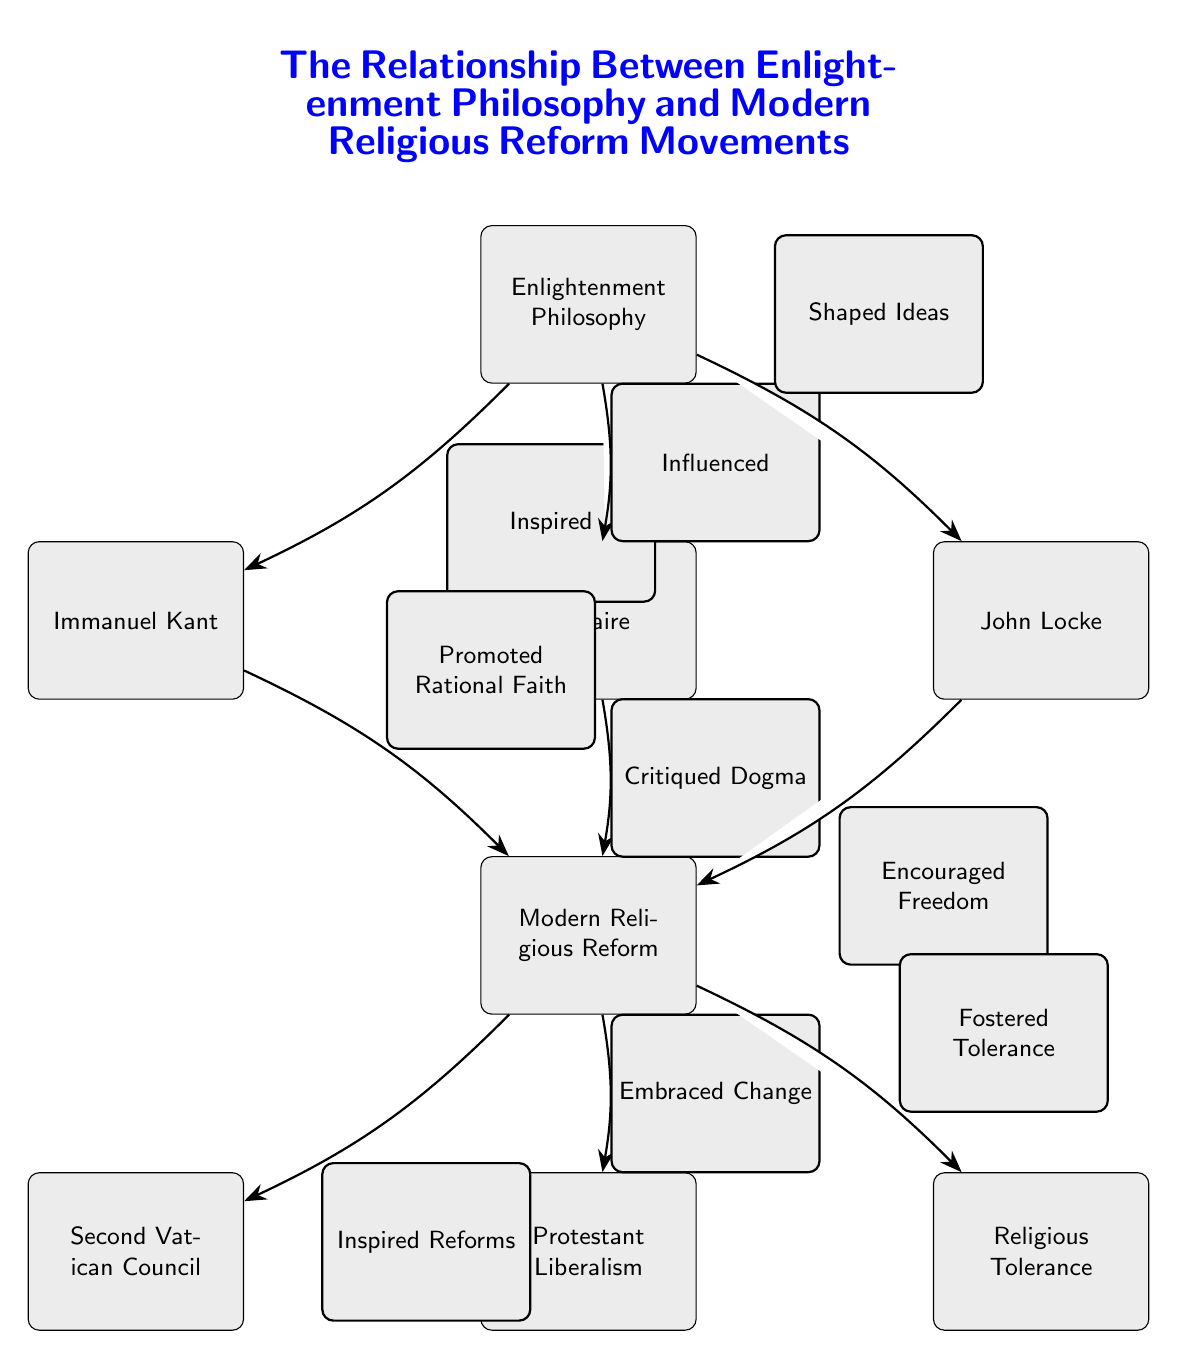What is the main concept at the top of the diagram? The concept at the top of the diagram is labeled as "Enlightenment Philosophy." This is the central idea from which the other nodes branch out.
Answer: Enlightenment Philosophy How many philosophers are represented in the diagram? The diagram showcases three philosophers: Immanuel Kant, Voltaire, and John Locke. These three are directly linked to the central idea of Enlightenment Philosophy.
Answer: 3 What does Voltaire's influence on Modern Religious Reform entail? According to the diagram, Voltaire's influence is described as "Critiqued Dogma," which indicates that he challenged established religious beliefs, prompting reformation in the context of modern religious practices.
Answer: Critiqued Dogma Which religious reform movement is connected to the encouragement of freedom? The diagram shows that John Locke's ideas "Encouraged Freedom," which is linked to the node representing Modern Religious Reform, specifically indicating a connection to the broader movement of modern religious changes.
Answer: Encouraged Freedom What is the relationship type that describes the connection between Enlightenment Philosophy and Immanuel Kant? The relationship described is "Inspired." This indicates that Enlightenment Philosophy served as a source of inspiration for Kant's ideas, impacting modern thought and reform.
Answer: Inspired How does Modern Religious Reform relate to Religious Tolerance? The diagram highlights that Modern Religious Reform "Fostered Tolerance," showcasing a direct influence from modern reform movements on the acceptance of varied beliefs and practices.
Answer: Fostered Tolerance What is the title of this diagram? The title is clearly stated as "The Relationship Between Enlightenment Philosophy and Modern Religious Reform Movements," which encapsulates the entire theme of the diagram based on the flow of ideas portrayed.
Answer: The Relationship Between Enlightenment Philosophy and Modern Religious Reform Movements Which reform movement directly follows from the Second Vatican Council in the diagram's flow? The diagram indicates that Protestant Liberalism directly follows as a movement that is influenced by the ideas stemming from Modern Religious Reform, underlining its development in this context.
Answer: Protestant Liberalism How many total connections (edges) are shown in the diagram? By counting the edges connecting various nodes, it is seen that there are a total of seven connections in the diagram, illustrating the complexity of relationships among the concepts.
Answer: 7 